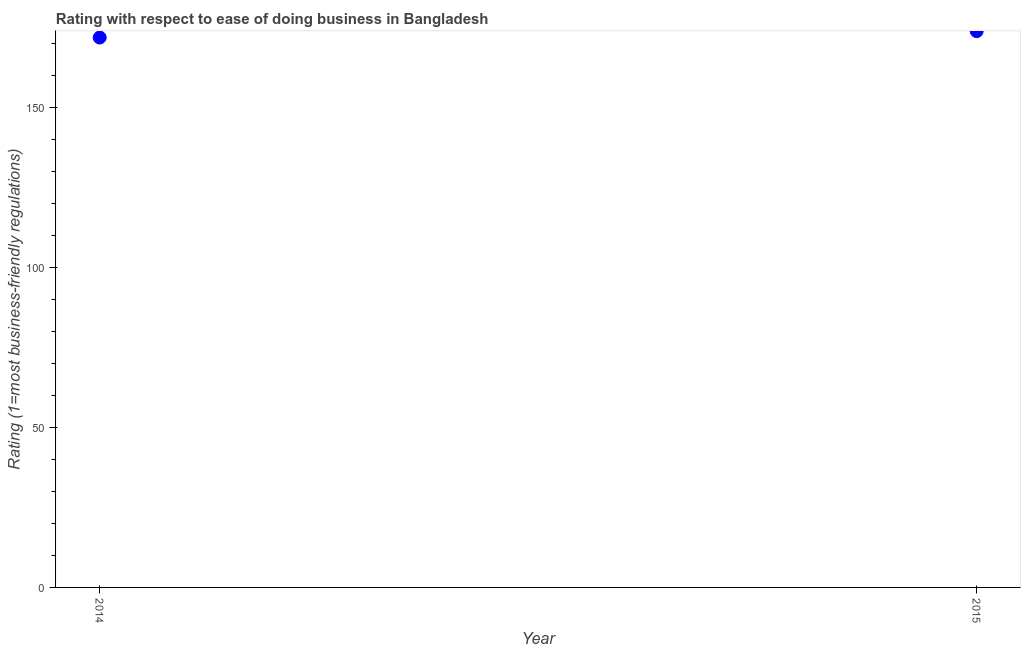What is the ease of doing business index in 2014?
Offer a terse response. 172. Across all years, what is the maximum ease of doing business index?
Your response must be concise. 174. Across all years, what is the minimum ease of doing business index?
Your answer should be compact. 172. In which year was the ease of doing business index maximum?
Provide a succinct answer. 2015. What is the sum of the ease of doing business index?
Ensure brevity in your answer.  346. What is the difference between the ease of doing business index in 2014 and 2015?
Offer a terse response. -2. What is the average ease of doing business index per year?
Your answer should be compact. 173. What is the median ease of doing business index?
Provide a succinct answer. 173. In how many years, is the ease of doing business index greater than 20 ?
Offer a very short reply. 2. Do a majority of the years between 2015 and 2014 (inclusive) have ease of doing business index greater than 20 ?
Provide a short and direct response. No. What is the ratio of the ease of doing business index in 2014 to that in 2015?
Make the answer very short. 0.99. In how many years, is the ease of doing business index greater than the average ease of doing business index taken over all years?
Provide a succinct answer. 1. Does the ease of doing business index monotonically increase over the years?
Your response must be concise. Yes. How many years are there in the graph?
Your answer should be compact. 2. What is the title of the graph?
Your response must be concise. Rating with respect to ease of doing business in Bangladesh. What is the label or title of the Y-axis?
Offer a terse response. Rating (1=most business-friendly regulations). What is the Rating (1=most business-friendly regulations) in 2014?
Offer a very short reply. 172. What is the Rating (1=most business-friendly regulations) in 2015?
Offer a very short reply. 174. What is the difference between the Rating (1=most business-friendly regulations) in 2014 and 2015?
Provide a short and direct response. -2. What is the ratio of the Rating (1=most business-friendly regulations) in 2014 to that in 2015?
Offer a terse response. 0.99. 